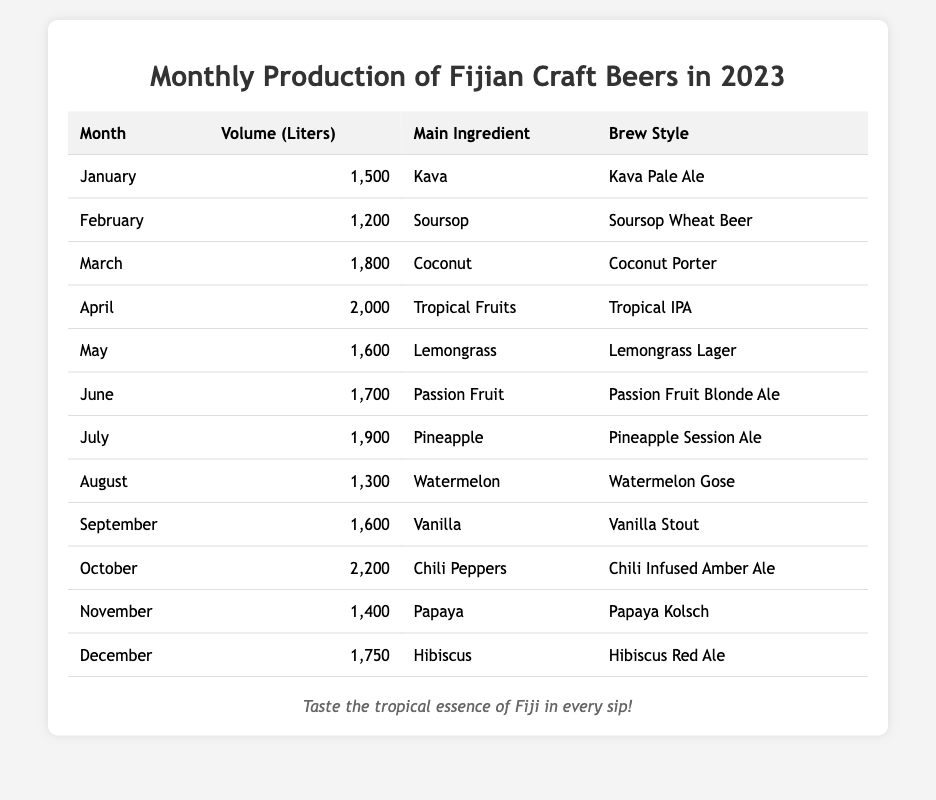What's the total production volume for the month of October? The table shows that the volume of production in October is 2,200 liters.
Answer: 2,200 liters Which month had the highest production volume? The table indicates that October has the highest production volume at 2,200 liters.
Answer: October What was the volume of beer produced in March? The table lists the volume produced in March as 1,800 liters.
Answer: 1,800 liters How many liters of craft beer were produced in June? The production volume for June is recorded as 1,700 liters in the table.
Answer: 1,700 liters What is the average production volume for the first half of the year (January to June)? The total production from January to June is 1,500 + 1,200 + 1,800 + 2,000 + 1,600 + 1,700 = 10,800 liters. As there are 6 months, the average is 10,800 / 6 = 1,800 liters.
Answer: 1,800 liters What is the difference in volume between April and August? April production is 2,000 liters and August production is 1,300 liters. The difference is 2,000 - 1,300 = 700 liters.
Answer: 700 liters Did the production volume increase from May to June? May's production is 1,600 liters and June's is 1,700 liters, indicating an increase (1,700 > 1,600).
Answer: Yes In which month was the Lemongrass Lager produced? The table shows that the Lemongrass Lager was produced in May.
Answer: May What was the production volume for Soursop Wheat Beer? The volume for Soursop Wheat Beer produced in February is 1,200 liters.
Answer: 1,200 liters What is the total production volume from July to December? The production volumes from July to December are 1,900 + 1,300 + 1,600 + 2,200 + 1,400 + 1,750 = 10,150 liters.
Answer: 10,150 liters Is the main ingredient for the beer produced in November Papaya? The table confirms that the main ingredient for the beer produced in November is indeed Papaya.
Answer: Yes Which brew style has the highest volume of production? The table shows that the Chili Infused Amber Ale produced in October has the highest volume at 2,200 liters.
Answer: Chili Infused Amber Ale How does the production volume in December compare to that in February? December's production is 1,750 liters and February's is 1,200 liters, meaning December has a higher volume: 1,750 > 1,200.
Answer: Higher in December What is the combined production volume of beers produced with fruit ingredients (January to December)? The sum of the volumes for all months with fruit ingredients (Soursop, Coconut, Tropical Fruits, Passion Fruit, Pineapple, Watermelon, Vanilla, Papaya, Hibiscus) is: 1,200 + 1,800 + 2,000 + 1,700 + 1,900 + 1,300 + 1,600 + 1,400 + 1,750 = 15,450 liters.
Answer: 15,450 liters 